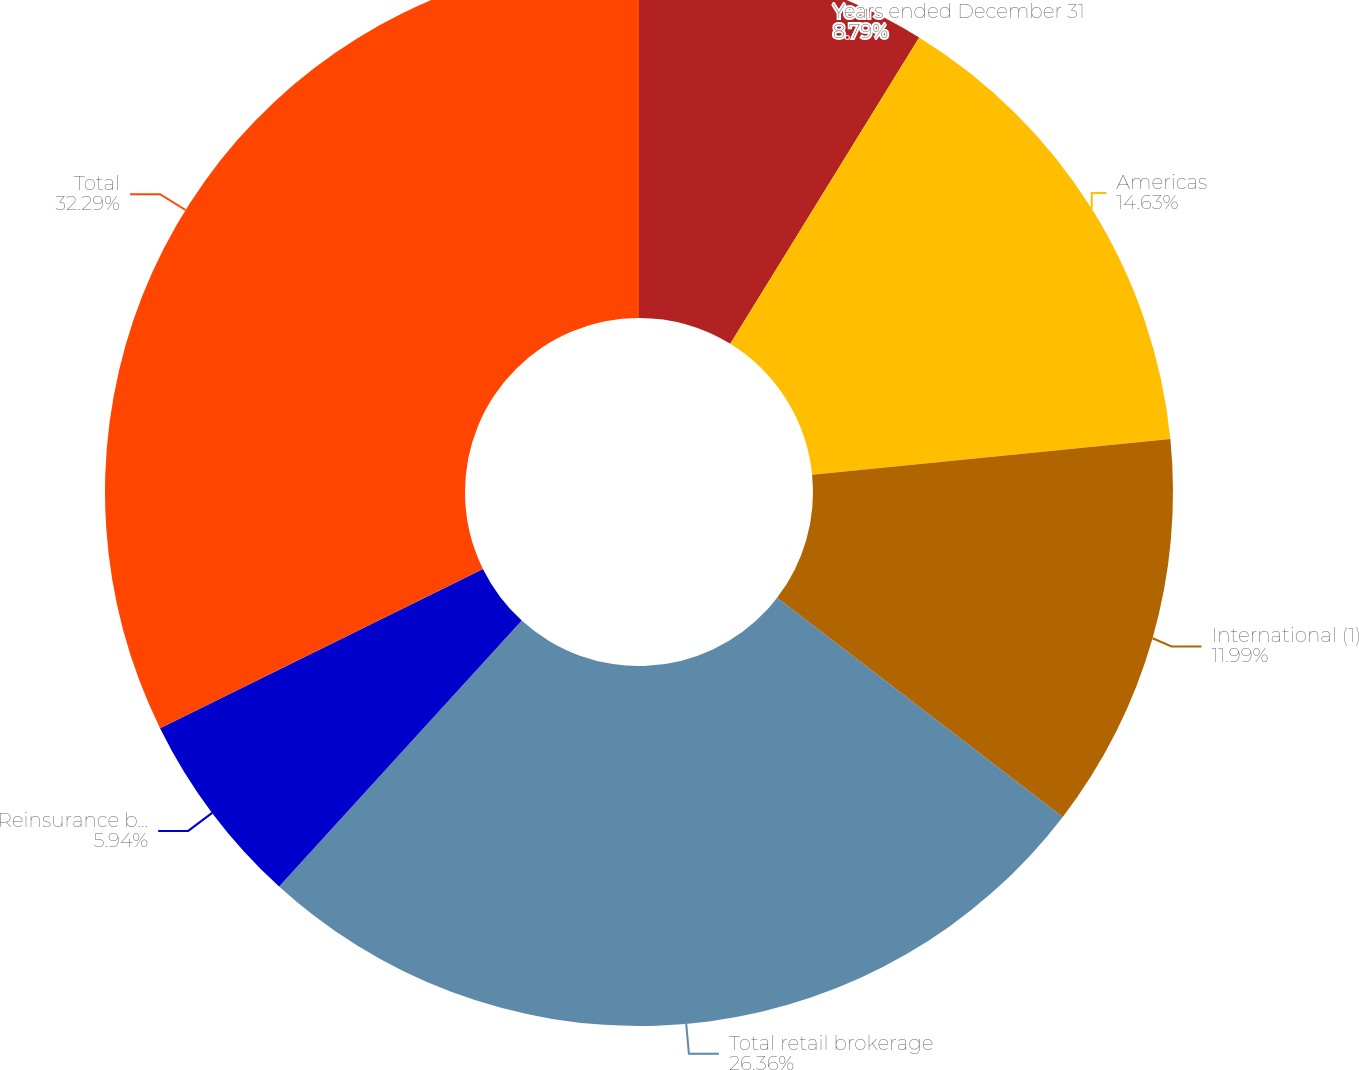Convert chart to OTSL. <chart><loc_0><loc_0><loc_500><loc_500><pie_chart><fcel>Years ended December 31<fcel>Americas<fcel>International (1)<fcel>Total retail brokerage<fcel>Reinsurance brokerage<fcel>Total<nl><fcel>8.79%<fcel>14.63%<fcel>11.99%<fcel>26.36%<fcel>5.94%<fcel>32.29%<nl></chart> 